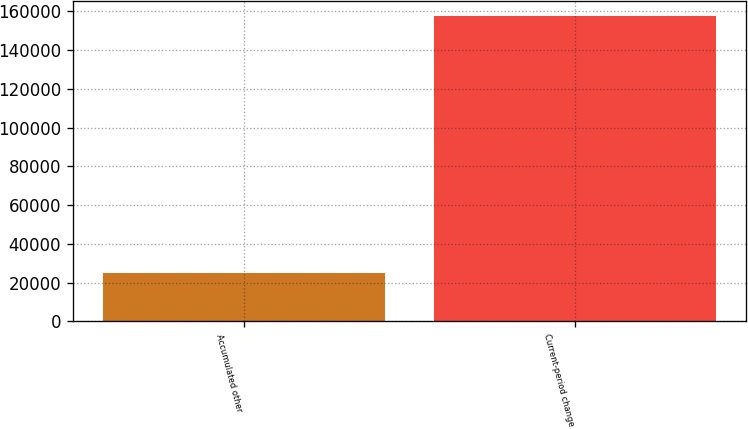Convert chart. <chart><loc_0><loc_0><loc_500><loc_500><bar_chart><fcel>Accumulated other<fcel>Current-period change<nl><fcel>25066<fcel>157667<nl></chart> 